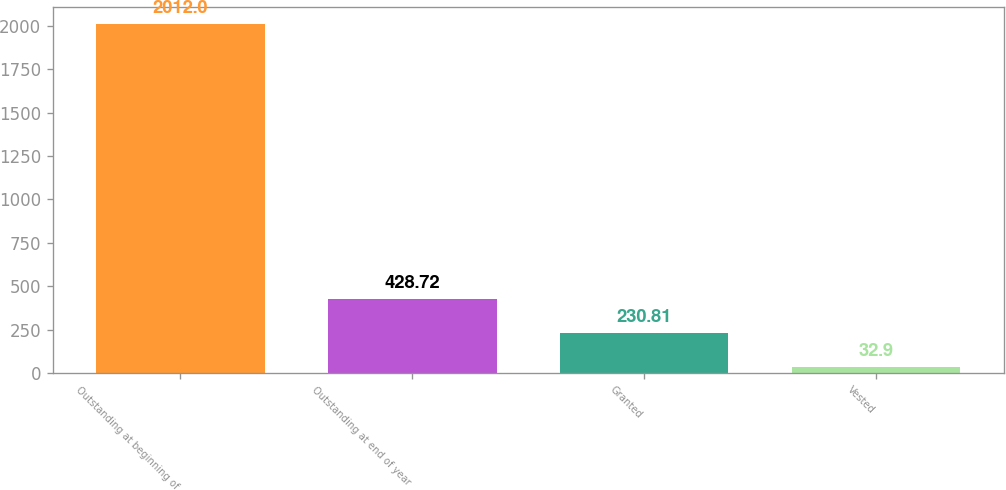Convert chart. <chart><loc_0><loc_0><loc_500><loc_500><bar_chart><fcel>Outstanding at beginning of<fcel>Outstanding at end of year<fcel>Granted<fcel>Vested<nl><fcel>2012<fcel>428.72<fcel>230.81<fcel>32.9<nl></chart> 